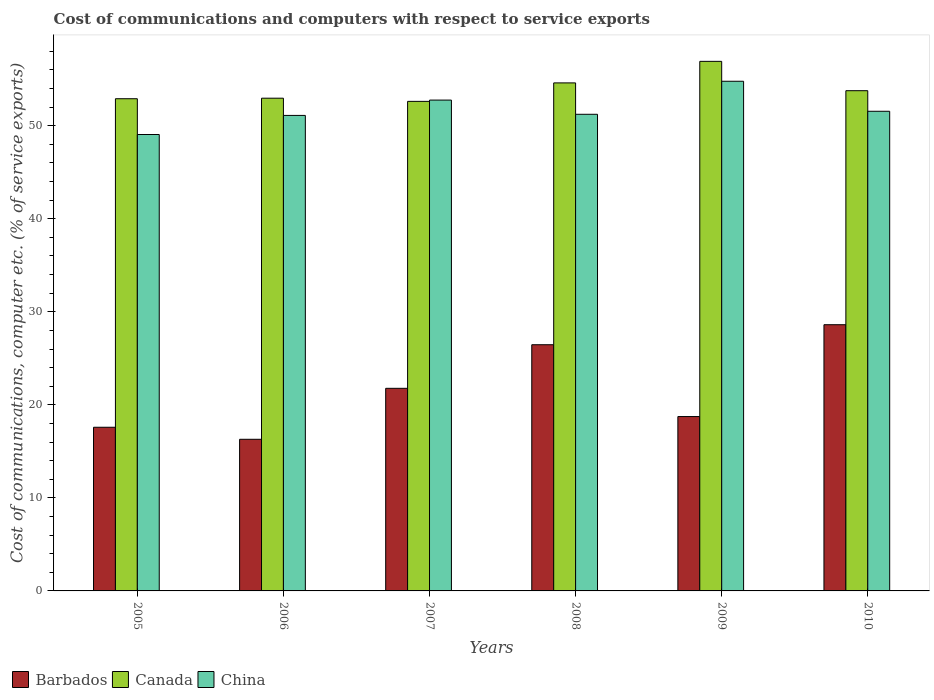How many different coloured bars are there?
Ensure brevity in your answer.  3. What is the label of the 6th group of bars from the left?
Give a very brief answer. 2010. What is the cost of communications and computers in China in 2006?
Your answer should be very brief. 51.11. Across all years, what is the maximum cost of communications and computers in Barbados?
Offer a very short reply. 28.61. Across all years, what is the minimum cost of communications and computers in Barbados?
Provide a short and direct response. 16.3. In which year was the cost of communications and computers in Barbados maximum?
Keep it short and to the point. 2010. What is the total cost of communications and computers in China in the graph?
Make the answer very short. 310.48. What is the difference between the cost of communications and computers in Canada in 2005 and that in 2008?
Your answer should be very brief. -1.7. What is the difference between the cost of communications and computers in Canada in 2008 and the cost of communications and computers in China in 2007?
Your answer should be very brief. 1.85. What is the average cost of communications and computers in Barbados per year?
Provide a succinct answer. 21.58. In the year 2006, what is the difference between the cost of communications and computers in Barbados and cost of communications and computers in China?
Make the answer very short. -34.81. What is the ratio of the cost of communications and computers in Barbados in 2006 to that in 2008?
Ensure brevity in your answer.  0.62. What is the difference between the highest and the second highest cost of communications and computers in Canada?
Keep it short and to the point. 2.32. What is the difference between the highest and the lowest cost of communications and computers in Barbados?
Ensure brevity in your answer.  12.31. What does the 1st bar from the left in 2006 represents?
Ensure brevity in your answer.  Barbados. How many bars are there?
Your response must be concise. 18. Are all the bars in the graph horizontal?
Provide a short and direct response. No. How many years are there in the graph?
Your answer should be very brief. 6. Are the values on the major ticks of Y-axis written in scientific E-notation?
Your answer should be compact. No. Does the graph contain grids?
Make the answer very short. No. What is the title of the graph?
Give a very brief answer. Cost of communications and computers with respect to service exports. What is the label or title of the X-axis?
Make the answer very short. Years. What is the label or title of the Y-axis?
Give a very brief answer. Cost of communications, computer etc. (% of service exports). What is the Cost of communications, computer etc. (% of service exports) in Barbados in 2005?
Provide a short and direct response. 17.59. What is the Cost of communications, computer etc. (% of service exports) in Canada in 2005?
Keep it short and to the point. 52.9. What is the Cost of communications, computer etc. (% of service exports) in China in 2005?
Keep it short and to the point. 49.06. What is the Cost of communications, computer etc. (% of service exports) of Barbados in 2006?
Give a very brief answer. 16.3. What is the Cost of communications, computer etc. (% of service exports) of Canada in 2006?
Keep it short and to the point. 52.96. What is the Cost of communications, computer etc. (% of service exports) of China in 2006?
Offer a very short reply. 51.11. What is the Cost of communications, computer etc. (% of service exports) of Barbados in 2007?
Keep it short and to the point. 21.77. What is the Cost of communications, computer etc. (% of service exports) of Canada in 2007?
Give a very brief answer. 52.62. What is the Cost of communications, computer etc. (% of service exports) in China in 2007?
Your answer should be compact. 52.76. What is the Cost of communications, computer etc. (% of service exports) in Barbados in 2008?
Make the answer very short. 26.46. What is the Cost of communications, computer etc. (% of service exports) of Canada in 2008?
Provide a succinct answer. 54.6. What is the Cost of communications, computer etc. (% of service exports) of China in 2008?
Your answer should be very brief. 51.23. What is the Cost of communications, computer etc. (% of service exports) in Barbados in 2009?
Offer a very short reply. 18.74. What is the Cost of communications, computer etc. (% of service exports) in Canada in 2009?
Give a very brief answer. 56.92. What is the Cost of communications, computer etc. (% of service exports) in China in 2009?
Your response must be concise. 54.78. What is the Cost of communications, computer etc. (% of service exports) of Barbados in 2010?
Offer a terse response. 28.61. What is the Cost of communications, computer etc. (% of service exports) of Canada in 2010?
Offer a very short reply. 53.76. What is the Cost of communications, computer etc. (% of service exports) in China in 2010?
Offer a very short reply. 51.55. Across all years, what is the maximum Cost of communications, computer etc. (% of service exports) in Barbados?
Keep it short and to the point. 28.61. Across all years, what is the maximum Cost of communications, computer etc. (% of service exports) in Canada?
Your answer should be very brief. 56.92. Across all years, what is the maximum Cost of communications, computer etc. (% of service exports) in China?
Make the answer very short. 54.78. Across all years, what is the minimum Cost of communications, computer etc. (% of service exports) of Barbados?
Ensure brevity in your answer.  16.3. Across all years, what is the minimum Cost of communications, computer etc. (% of service exports) in Canada?
Your response must be concise. 52.62. Across all years, what is the minimum Cost of communications, computer etc. (% of service exports) of China?
Provide a short and direct response. 49.06. What is the total Cost of communications, computer etc. (% of service exports) of Barbados in the graph?
Keep it short and to the point. 129.48. What is the total Cost of communications, computer etc. (% of service exports) of Canada in the graph?
Provide a short and direct response. 323.76. What is the total Cost of communications, computer etc. (% of service exports) of China in the graph?
Your answer should be very brief. 310.48. What is the difference between the Cost of communications, computer etc. (% of service exports) of Barbados in 2005 and that in 2006?
Keep it short and to the point. 1.29. What is the difference between the Cost of communications, computer etc. (% of service exports) of Canada in 2005 and that in 2006?
Your answer should be compact. -0.06. What is the difference between the Cost of communications, computer etc. (% of service exports) in China in 2005 and that in 2006?
Ensure brevity in your answer.  -2.05. What is the difference between the Cost of communications, computer etc. (% of service exports) of Barbados in 2005 and that in 2007?
Provide a succinct answer. -4.18. What is the difference between the Cost of communications, computer etc. (% of service exports) of Canada in 2005 and that in 2007?
Keep it short and to the point. 0.28. What is the difference between the Cost of communications, computer etc. (% of service exports) in China in 2005 and that in 2007?
Provide a short and direct response. -3.7. What is the difference between the Cost of communications, computer etc. (% of service exports) of Barbados in 2005 and that in 2008?
Provide a succinct answer. -8.87. What is the difference between the Cost of communications, computer etc. (% of service exports) in Canada in 2005 and that in 2008?
Ensure brevity in your answer.  -1.7. What is the difference between the Cost of communications, computer etc. (% of service exports) of China in 2005 and that in 2008?
Provide a succinct answer. -2.17. What is the difference between the Cost of communications, computer etc. (% of service exports) in Barbados in 2005 and that in 2009?
Keep it short and to the point. -1.15. What is the difference between the Cost of communications, computer etc. (% of service exports) of Canada in 2005 and that in 2009?
Offer a very short reply. -4.02. What is the difference between the Cost of communications, computer etc. (% of service exports) in China in 2005 and that in 2009?
Your response must be concise. -5.72. What is the difference between the Cost of communications, computer etc. (% of service exports) in Barbados in 2005 and that in 2010?
Offer a terse response. -11.02. What is the difference between the Cost of communications, computer etc. (% of service exports) of Canada in 2005 and that in 2010?
Your answer should be very brief. -0.86. What is the difference between the Cost of communications, computer etc. (% of service exports) of China in 2005 and that in 2010?
Keep it short and to the point. -2.5. What is the difference between the Cost of communications, computer etc. (% of service exports) of Barbados in 2006 and that in 2007?
Offer a very short reply. -5.48. What is the difference between the Cost of communications, computer etc. (% of service exports) of Canada in 2006 and that in 2007?
Offer a terse response. 0.34. What is the difference between the Cost of communications, computer etc. (% of service exports) of China in 2006 and that in 2007?
Your response must be concise. -1.65. What is the difference between the Cost of communications, computer etc. (% of service exports) of Barbados in 2006 and that in 2008?
Provide a short and direct response. -10.16. What is the difference between the Cost of communications, computer etc. (% of service exports) of Canada in 2006 and that in 2008?
Your response must be concise. -1.64. What is the difference between the Cost of communications, computer etc. (% of service exports) of China in 2006 and that in 2008?
Your answer should be very brief. -0.12. What is the difference between the Cost of communications, computer etc. (% of service exports) in Barbados in 2006 and that in 2009?
Provide a short and direct response. -2.44. What is the difference between the Cost of communications, computer etc. (% of service exports) of Canada in 2006 and that in 2009?
Give a very brief answer. -3.96. What is the difference between the Cost of communications, computer etc. (% of service exports) in China in 2006 and that in 2009?
Provide a succinct answer. -3.67. What is the difference between the Cost of communications, computer etc. (% of service exports) of Barbados in 2006 and that in 2010?
Make the answer very short. -12.31. What is the difference between the Cost of communications, computer etc. (% of service exports) in Canada in 2006 and that in 2010?
Your answer should be compact. -0.81. What is the difference between the Cost of communications, computer etc. (% of service exports) of China in 2006 and that in 2010?
Give a very brief answer. -0.45. What is the difference between the Cost of communications, computer etc. (% of service exports) of Barbados in 2007 and that in 2008?
Offer a terse response. -4.69. What is the difference between the Cost of communications, computer etc. (% of service exports) of Canada in 2007 and that in 2008?
Your answer should be very brief. -1.99. What is the difference between the Cost of communications, computer etc. (% of service exports) in China in 2007 and that in 2008?
Ensure brevity in your answer.  1.53. What is the difference between the Cost of communications, computer etc. (% of service exports) in Barbados in 2007 and that in 2009?
Ensure brevity in your answer.  3.03. What is the difference between the Cost of communications, computer etc. (% of service exports) in Canada in 2007 and that in 2009?
Ensure brevity in your answer.  -4.3. What is the difference between the Cost of communications, computer etc. (% of service exports) in China in 2007 and that in 2009?
Ensure brevity in your answer.  -2.02. What is the difference between the Cost of communications, computer etc. (% of service exports) of Barbados in 2007 and that in 2010?
Your answer should be very brief. -6.84. What is the difference between the Cost of communications, computer etc. (% of service exports) in Canada in 2007 and that in 2010?
Provide a succinct answer. -1.15. What is the difference between the Cost of communications, computer etc. (% of service exports) of China in 2007 and that in 2010?
Your answer should be compact. 1.2. What is the difference between the Cost of communications, computer etc. (% of service exports) in Barbados in 2008 and that in 2009?
Your response must be concise. 7.72. What is the difference between the Cost of communications, computer etc. (% of service exports) of Canada in 2008 and that in 2009?
Your answer should be compact. -2.32. What is the difference between the Cost of communications, computer etc. (% of service exports) of China in 2008 and that in 2009?
Offer a terse response. -3.55. What is the difference between the Cost of communications, computer etc. (% of service exports) of Barbados in 2008 and that in 2010?
Ensure brevity in your answer.  -2.15. What is the difference between the Cost of communications, computer etc. (% of service exports) of Canada in 2008 and that in 2010?
Make the answer very short. 0.84. What is the difference between the Cost of communications, computer etc. (% of service exports) in China in 2008 and that in 2010?
Ensure brevity in your answer.  -0.33. What is the difference between the Cost of communications, computer etc. (% of service exports) of Barbados in 2009 and that in 2010?
Give a very brief answer. -9.87. What is the difference between the Cost of communications, computer etc. (% of service exports) of Canada in 2009 and that in 2010?
Provide a succinct answer. 3.15. What is the difference between the Cost of communications, computer etc. (% of service exports) in China in 2009 and that in 2010?
Offer a terse response. 3.23. What is the difference between the Cost of communications, computer etc. (% of service exports) of Barbados in 2005 and the Cost of communications, computer etc. (% of service exports) of Canada in 2006?
Provide a succinct answer. -35.37. What is the difference between the Cost of communications, computer etc. (% of service exports) of Barbados in 2005 and the Cost of communications, computer etc. (% of service exports) of China in 2006?
Ensure brevity in your answer.  -33.52. What is the difference between the Cost of communications, computer etc. (% of service exports) in Canada in 2005 and the Cost of communications, computer etc. (% of service exports) in China in 2006?
Offer a very short reply. 1.79. What is the difference between the Cost of communications, computer etc. (% of service exports) of Barbados in 2005 and the Cost of communications, computer etc. (% of service exports) of Canada in 2007?
Your answer should be compact. -35.03. What is the difference between the Cost of communications, computer etc. (% of service exports) of Barbados in 2005 and the Cost of communications, computer etc. (% of service exports) of China in 2007?
Offer a terse response. -35.16. What is the difference between the Cost of communications, computer etc. (% of service exports) in Canada in 2005 and the Cost of communications, computer etc. (% of service exports) in China in 2007?
Provide a succinct answer. 0.14. What is the difference between the Cost of communications, computer etc. (% of service exports) of Barbados in 2005 and the Cost of communications, computer etc. (% of service exports) of Canada in 2008?
Ensure brevity in your answer.  -37.01. What is the difference between the Cost of communications, computer etc. (% of service exports) in Barbados in 2005 and the Cost of communications, computer etc. (% of service exports) in China in 2008?
Your answer should be compact. -33.64. What is the difference between the Cost of communications, computer etc. (% of service exports) of Canada in 2005 and the Cost of communications, computer etc. (% of service exports) of China in 2008?
Provide a succinct answer. 1.67. What is the difference between the Cost of communications, computer etc. (% of service exports) in Barbados in 2005 and the Cost of communications, computer etc. (% of service exports) in Canada in 2009?
Your answer should be very brief. -39.33. What is the difference between the Cost of communications, computer etc. (% of service exports) of Barbados in 2005 and the Cost of communications, computer etc. (% of service exports) of China in 2009?
Provide a succinct answer. -37.19. What is the difference between the Cost of communications, computer etc. (% of service exports) in Canada in 2005 and the Cost of communications, computer etc. (% of service exports) in China in 2009?
Offer a very short reply. -1.88. What is the difference between the Cost of communications, computer etc. (% of service exports) in Barbados in 2005 and the Cost of communications, computer etc. (% of service exports) in Canada in 2010?
Make the answer very short. -36.17. What is the difference between the Cost of communications, computer etc. (% of service exports) in Barbados in 2005 and the Cost of communications, computer etc. (% of service exports) in China in 2010?
Make the answer very short. -33.96. What is the difference between the Cost of communications, computer etc. (% of service exports) in Canada in 2005 and the Cost of communications, computer etc. (% of service exports) in China in 2010?
Provide a short and direct response. 1.35. What is the difference between the Cost of communications, computer etc. (% of service exports) of Barbados in 2006 and the Cost of communications, computer etc. (% of service exports) of Canada in 2007?
Your answer should be very brief. -36.32. What is the difference between the Cost of communications, computer etc. (% of service exports) in Barbados in 2006 and the Cost of communications, computer etc. (% of service exports) in China in 2007?
Keep it short and to the point. -36.46. What is the difference between the Cost of communications, computer etc. (% of service exports) of Canada in 2006 and the Cost of communications, computer etc. (% of service exports) of China in 2007?
Your response must be concise. 0.2. What is the difference between the Cost of communications, computer etc. (% of service exports) in Barbados in 2006 and the Cost of communications, computer etc. (% of service exports) in Canada in 2008?
Offer a very short reply. -38.3. What is the difference between the Cost of communications, computer etc. (% of service exports) in Barbados in 2006 and the Cost of communications, computer etc. (% of service exports) in China in 2008?
Provide a short and direct response. -34.93. What is the difference between the Cost of communications, computer etc. (% of service exports) of Canada in 2006 and the Cost of communications, computer etc. (% of service exports) of China in 2008?
Provide a short and direct response. 1.73. What is the difference between the Cost of communications, computer etc. (% of service exports) of Barbados in 2006 and the Cost of communications, computer etc. (% of service exports) of Canada in 2009?
Your response must be concise. -40.62. What is the difference between the Cost of communications, computer etc. (% of service exports) in Barbados in 2006 and the Cost of communications, computer etc. (% of service exports) in China in 2009?
Your answer should be very brief. -38.48. What is the difference between the Cost of communications, computer etc. (% of service exports) of Canada in 2006 and the Cost of communications, computer etc. (% of service exports) of China in 2009?
Offer a very short reply. -1.82. What is the difference between the Cost of communications, computer etc. (% of service exports) in Barbados in 2006 and the Cost of communications, computer etc. (% of service exports) in Canada in 2010?
Your answer should be very brief. -37.47. What is the difference between the Cost of communications, computer etc. (% of service exports) of Barbados in 2006 and the Cost of communications, computer etc. (% of service exports) of China in 2010?
Make the answer very short. -35.26. What is the difference between the Cost of communications, computer etc. (% of service exports) in Canada in 2006 and the Cost of communications, computer etc. (% of service exports) in China in 2010?
Your response must be concise. 1.41. What is the difference between the Cost of communications, computer etc. (% of service exports) in Barbados in 2007 and the Cost of communications, computer etc. (% of service exports) in Canada in 2008?
Ensure brevity in your answer.  -32.83. What is the difference between the Cost of communications, computer etc. (% of service exports) in Barbados in 2007 and the Cost of communications, computer etc. (% of service exports) in China in 2008?
Your answer should be compact. -29.45. What is the difference between the Cost of communications, computer etc. (% of service exports) of Canada in 2007 and the Cost of communications, computer etc. (% of service exports) of China in 2008?
Make the answer very short. 1.39. What is the difference between the Cost of communications, computer etc. (% of service exports) of Barbados in 2007 and the Cost of communications, computer etc. (% of service exports) of Canada in 2009?
Keep it short and to the point. -35.14. What is the difference between the Cost of communications, computer etc. (% of service exports) of Barbados in 2007 and the Cost of communications, computer etc. (% of service exports) of China in 2009?
Keep it short and to the point. -33. What is the difference between the Cost of communications, computer etc. (% of service exports) of Canada in 2007 and the Cost of communications, computer etc. (% of service exports) of China in 2009?
Keep it short and to the point. -2.16. What is the difference between the Cost of communications, computer etc. (% of service exports) of Barbados in 2007 and the Cost of communications, computer etc. (% of service exports) of Canada in 2010?
Make the answer very short. -31.99. What is the difference between the Cost of communications, computer etc. (% of service exports) in Barbados in 2007 and the Cost of communications, computer etc. (% of service exports) in China in 2010?
Give a very brief answer. -29.78. What is the difference between the Cost of communications, computer etc. (% of service exports) in Canada in 2007 and the Cost of communications, computer etc. (% of service exports) in China in 2010?
Provide a short and direct response. 1.06. What is the difference between the Cost of communications, computer etc. (% of service exports) of Barbados in 2008 and the Cost of communications, computer etc. (% of service exports) of Canada in 2009?
Give a very brief answer. -30.46. What is the difference between the Cost of communications, computer etc. (% of service exports) of Barbados in 2008 and the Cost of communications, computer etc. (% of service exports) of China in 2009?
Ensure brevity in your answer.  -28.32. What is the difference between the Cost of communications, computer etc. (% of service exports) in Canada in 2008 and the Cost of communications, computer etc. (% of service exports) in China in 2009?
Ensure brevity in your answer.  -0.18. What is the difference between the Cost of communications, computer etc. (% of service exports) of Barbados in 2008 and the Cost of communications, computer etc. (% of service exports) of Canada in 2010?
Your answer should be very brief. -27.3. What is the difference between the Cost of communications, computer etc. (% of service exports) of Barbados in 2008 and the Cost of communications, computer etc. (% of service exports) of China in 2010?
Provide a succinct answer. -25.09. What is the difference between the Cost of communications, computer etc. (% of service exports) in Canada in 2008 and the Cost of communications, computer etc. (% of service exports) in China in 2010?
Make the answer very short. 3.05. What is the difference between the Cost of communications, computer etc. (% of service exports) of Barbados in 2009 and the Cost of communications, computer etc. (% of service exports) of Canada in 2010?
Your answer should be compact. -35.02. What is the difference between the Cost of communications, computer etc. (% of service exports) in Barbados in 2009 and the Cost of communications, computer etc. (% of service exports) in China in 2010?
Your answer should be compact. -32.81. What is the difference between the Cost of communications, computer etc. (% of service exports) of Canada in 2009 and the Cost of communications, computer etc. (% of service exports) of China in 2010?
Provide a succinct answer. 5.36. What is the average Cost of communications, computer etc. (% of service exports) of Barbados per year?
Give a very brief answer. 21.58. What is the average Cost of communications, computer etc. (% of service exports) in Canada per year?
Your answer should be very brief. 53.96. What is the average Cost of communications, computer etc. (% of service exports) in China per year?
Your answer should be very brief. 51.75. In the year 2005, what is the difference between the Cost of communications, computer etc. (% of service exports) in Barbados and Cost of communications, computer etc. (% of service exports) in Canada?
Offer a terse response. -35.31. In the year 2005, what is the difference between the Cost of communications, computer etc. (% of service exports) of Barbados and Cost of communications, computer etc. (% of service exports) of China?
Your answer should be very brief. -31.46. In the year 2005, what is the difference between the Cost of communications, computer etc. (% of service exports) in Canada and Cost of communications, computer etc. (% of service exports) in China?
Offer a very short reply. 3.84. In the year 2006, what is the difference between the Cost of communications, computer etc. (% of service exports) of Barbados and Cost of communications, computer etc. (% of service exports) of Canada?
Ensure brevity in your answer.  -36.66. In the year 2006, what is the difference between the Cost of communications, computer etc. (% of service exports) in Barbados and Cost of communications, computer etc. (% of service exports) in China?
Your answer should be very brief. -34.81. In the year 2006, what is the difference between the Cost of communications, computer etc. (% of service exports) of Canada and Cost of communications, computer etc. (% of service exports) of China?
Ensure brevity in your answer.  1.85. In the year 2007, what is the difference between the Cost of communications, computer etc. (% of service exports) in Barbados and Cost of communications, computer etc. (% of service exports) in Canada?
Offer a very short reply. -30.84. In the year 2007, what is the difference between the Cost of communications, computer etc. (% of service exports) of Barbados and Cost of communications, computer etc. (% of service exports) of China?
Provide a short and direct response. -30.98. In the year 2007, what is the difference between the Cost of communications, computer etc. (% of service exports) in Canada and Cost of communications, computer etc. (% of service exports) in China?
Provide a succinct answer. -0.14. In the year 2008, what is the difference between the Cost of communications, computer etc. (% of service exports) in Barbados and Cost of communications, computer etc. (% of service exports) in Canada?
Your response must be concise. -28.14. In the year 2008, what is the difference between the Cost of communications, computer etc. (% of service exports) in Barbados and Cost of communications, computer etc. (% of service exports) in China?
Your response must be concise. -24.77. In the year 2008, what is the difference between the Cost of communications, computer etc. (% of service exports) of Canada and Cost of communications, computer etc. (% of service exports) of China?
Provide a short and direct response. 3.38. In the year 2009, what is the difference between the Cost of communications, computer etc. (% of service exports) in Barbados and Cost of communications, computer etc. (% of service exports) in Canada?
Your response must be concise. -38.18. In the year 2009, what is the difference between the Cost of communications, computer etc. (% of service exports) of Barbados and Cost of communications, computer etc. (% of service exports) of China?
Keep it short and to the point. -36.04. In the year 2009, what is the difference between the Cost of communications, computer etc. (% of service exports) of Canada and Cost of communications, computer etc. (% of service exports) of China?
Keep it short and to the point. 2.14. In the year 2010, what is the difference between the Cost of communications, computer etc. (% of service exports) of Barbados and Cost of communications, computer etc. (% of service exports) of Canada?
Offer a very short reply. -25.15. In the year 2010, what is the difference between the Cost of communications, computer etc. (% of service exports) in Barbados and Cost of communications, computer etc. (% of service exports) in China?
Your response must be concise. -22.94. In the year 2010, what is the difference between the Cost of communications, computer etc. (% of service exports) of Canada and Cost of communications, computer etc. (% of service exports) of China?
Give a very brief answer. 2.21. What is the ratio of the Cost of communications, computer etc. (% of service exports) of Barbados in 2005 to that in 2006?
Ensure brevity in your answer.  1.08. What is the ratio of the Cost of communications, computer etc. (% of service exports) in China in 2005 to that in 2006?
Make the answer very short. 0.96. What is the ratio of the Cost of communications, computer etc. (% of service exports) of Barbados in 2005 to that in 2007?
Your answer should be very brief. 0.81. What is the ratio of the Cost of communications, computer etc. (% of service exports) of Canada in 2005 to that in 2007?
Give a very brief answer. 1.01. What is the ratio of the Cost of communications, computer etc. (% of service exports) of China in 2005 to that in 2007?
Provide a short and direct response. 0.93. What is the ratio of the Cost of communications, computer etc. (% of service exports) in Barbados in 2005 to that in 2008?
Your answer should be compact. 0.66. What is the ratio of the Cost of communications, computer etc. (% of service exports) of Canada in 2005 to that in 2008?
Offer a terse response. 0.97. What is the ratio of the Cost of communications, computer etc. (% of service exports) of China in 2005 to that in 2008?
Offer a terse response. 0.96. What is the ratio of the Cost of communications, computer etc. (% of service exports) of Barbados in 2005 to that in 2009?
Your answer should be compact. 0.94. What is the ratio of the Cost of communications, computer etc. (% of service exports) of Canada in 2005 to that in 2009?
Offer a very short reply. 0.93. What is the ratio of the Cost of communications, computer etc. (% of service exports) of China in 2005 to that in 2009?
Provide a succinct answer. 0.9. What is the ratio of the Cost of communications, computer etc. (% of service exports) of Barbados in 2005 to that in 2010?
Provide a succinct answer. 0.61. What is the ratio of the Cost of communications, computer etc. (% of service exports) in Canada in 2005 to that in 2010?
Keep it short and to the point. 0.98. What is the ratio of the Cost of communications, computer etc. (% of service exports) of China in 2005 to that in 2010?
Provide a short and direct response. 0.95. What is the ratio of the Cost of communications, computer etc. (% of service exports) of Barbados in 2006 to that in 2007?
Your response must be concise. 0.75. What is the ratio of the Cost of communications, computer etc. (% of service exports) in China in 2006 to that in 2007?
Ensure brevity in your answer.  0.97. What is the ratio of the Cost of communications, computer etc. (% of service exports) in Barbados in 2006 to that in 2008?
Your response must be concise. 0.62. What is the ratio of the Cost of communications, computer etc. (% of service exports) of Canada in 2006 to that in 2008?
Ensure brevity in your answer.  0.97. What is the ratio of the Cost of communications, computer etc. (% of service exports) in China in 2006 to that in 2008?
Your response must be concise. 1. What is the ratio of the Cost of communications, computer etc. (% of service exports) of Barbados in 2006 to that in 2009?
Provide a succinct answer. 0.87. What is the ratio of the Cost of communications, computer etc. (% of service exports) in Canada in 2006 to that in 2009?
Give a very brief answer. 0.93. What is the ratio of the Cost of communications, computer etc. (% of service exports) in China in 2006 to that in 2009?
Your answer should be compact. 0.93. What is the ratio of the Cost of communications, computer etc. (% of service exports) in Barbados in 2006 to that in 2010?
Offer a very short reply. 0.57. What is the ratio of the Cost of communications, computer etc. (% of service exports) in Barbados in 2007 to that in 2008?
Your answer should be compact. 0.82. What is the ratio of the Cost of communications, computer etc. (% of service exports) of Canada in 2007 to that in 2008?
Keep it short and to the point. 0.96. What is the ratio of the Cost of communications, computer etc. (% of service exports) in China in 2007 to that in 2008?
Ensure brevity in your answer.  1.03. What is the ratio of the Cost of communications, computer etc. (% of service exports) of Barbados in 2007 to that in 2009?
Make the answer very short. 1.16. What is the ratio of the Cost of communications, computer etc. (% of service exports) in Canada in 2007 to that in 2009?
Make the answer very short. 0.92. What is the ratio of the Cost of communications, computer etc. (% of service exports) in China in 2007 to that in 2009?
Offer a terse response. 0.96. What is the ratio of the Cost of communications, computer etc. (% of service exports) in Barbados in 2007 to that in 2010?
Offer a terse response. 0.76. What is the ratio of the Cost of communications, computer etc. (% of service exports) of Canada in 2007 to that in 2010?
Keep it short and to the point. 0.98. What is the ratio of the Cost of communications, computer etc. (% of service exports) in China in 2007 to that in 2010?
Give a very brief answer. 1.02. What is the ratio of the Cost of communications, computer etc. (% of service exports) in Barbados in 2008 to that in 2009?
Give a very brief answer. 1.41. What is the ratio of the Cost of communications, computer etc. (% of service exports) of Canada in 2008 to that in 2009?
Offer a terse response. 0.96. What is the ratio of the Cost of communications, computer etc. (% of service exports) of China in 2008 to that in 2009?
Ensure brevity in your answer.  0.94. What is the ratio of the Cost of communications, computer etc. (% of service exports) of Barbados in 2008 to that in 2010?
Your answer should be very brief. 0.92. What is the ratio of the Cost of communications, computer etc. (% of service exports) of Canada in 2008 to that in 2010?
Keep it short and to the point. 1.02. What is the ratio of the Cost of communications, computer etc. (% of service exports) of China in 2008 to that in 2010?
Offer a terse response. 0.99. What is the ratio of the Cost of communications, computer etc. (% of service exports) in Barbados in 2009 to that in 2010?
Your answer should be compact. 0.66. What is the ratio of the Cost of communications, computer etc. (% of service exports) of Canada in 2009 to that in 2010?
Provide a short and direct response. 1.06. What is the ratio of the Cost of communications, computer etc. (% of service exports) in China in 2009 to that in 2010?
Provide a succinct answer. 1.06. What is the difference between the highest and the second highest Cost of communications, computer etc. (% of service exports) of Barbados?
Your answer should be very brief. 2.15. What is the difference between the highest and the second highest Cost of communications, computer etc. (% of service exports) of Canada?
Provide a succinct answer. 2.32. What is the difference between the highest and the second highest Cost of communications, computer etc. (% of service exports) of China?
Offer a terse response. 2.02. What is the difference between the highest and the lowest Cost of communications, computer etc. (% of service exports) of Barbados?
Your answer should be very brief. 12.31. What is the difference between the highest and the lowest Cost of communications, computer etc. (% of service exports) of Canada?
Your answer should be compact. 4.3. What is the difference between the highest and the lowest Cost of communications, computer etc. (% of service exports) of China?
Your response must be concise. 5.72. 